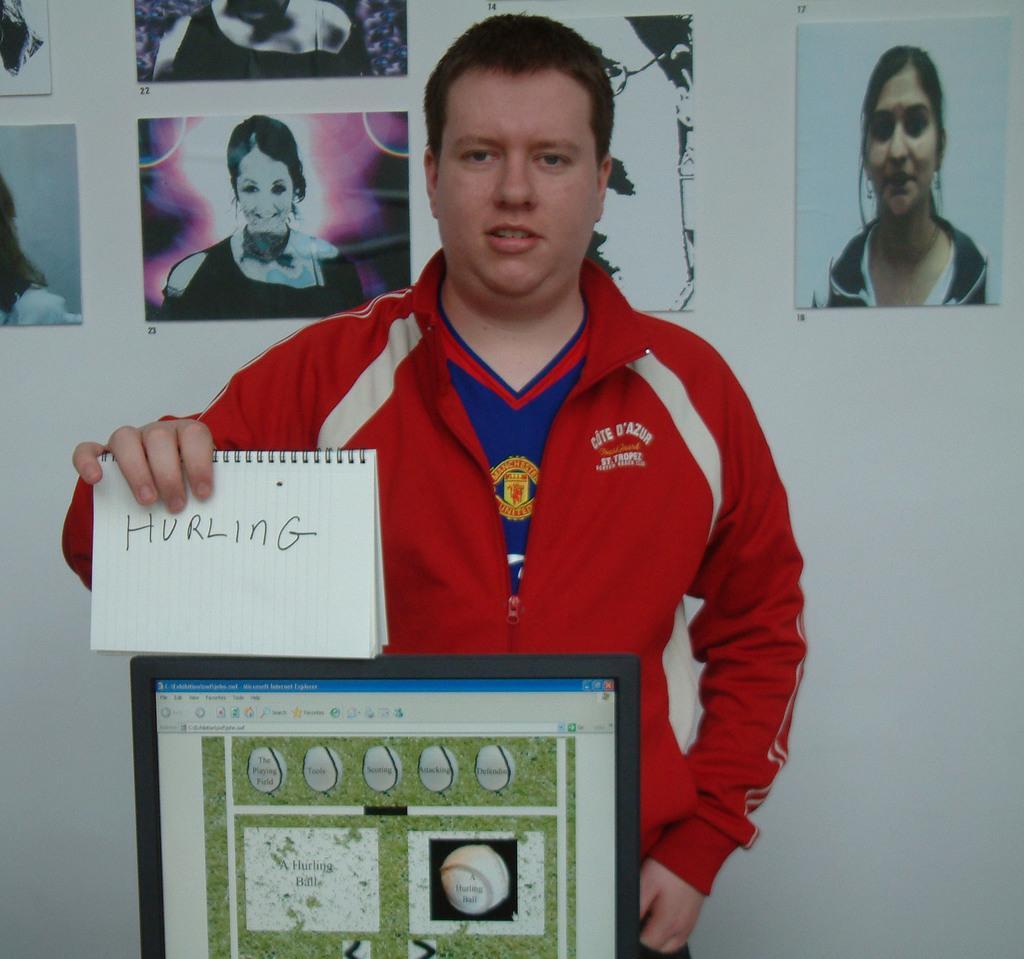In one or two sentences, can you explain what this image depicts? In this image I can see a man is standing and holding a notebook. I can see he is wearing blue dress and on it red jacket. I can also see something is written over here. In the background I can see few photos and here I can see a black monitor. 